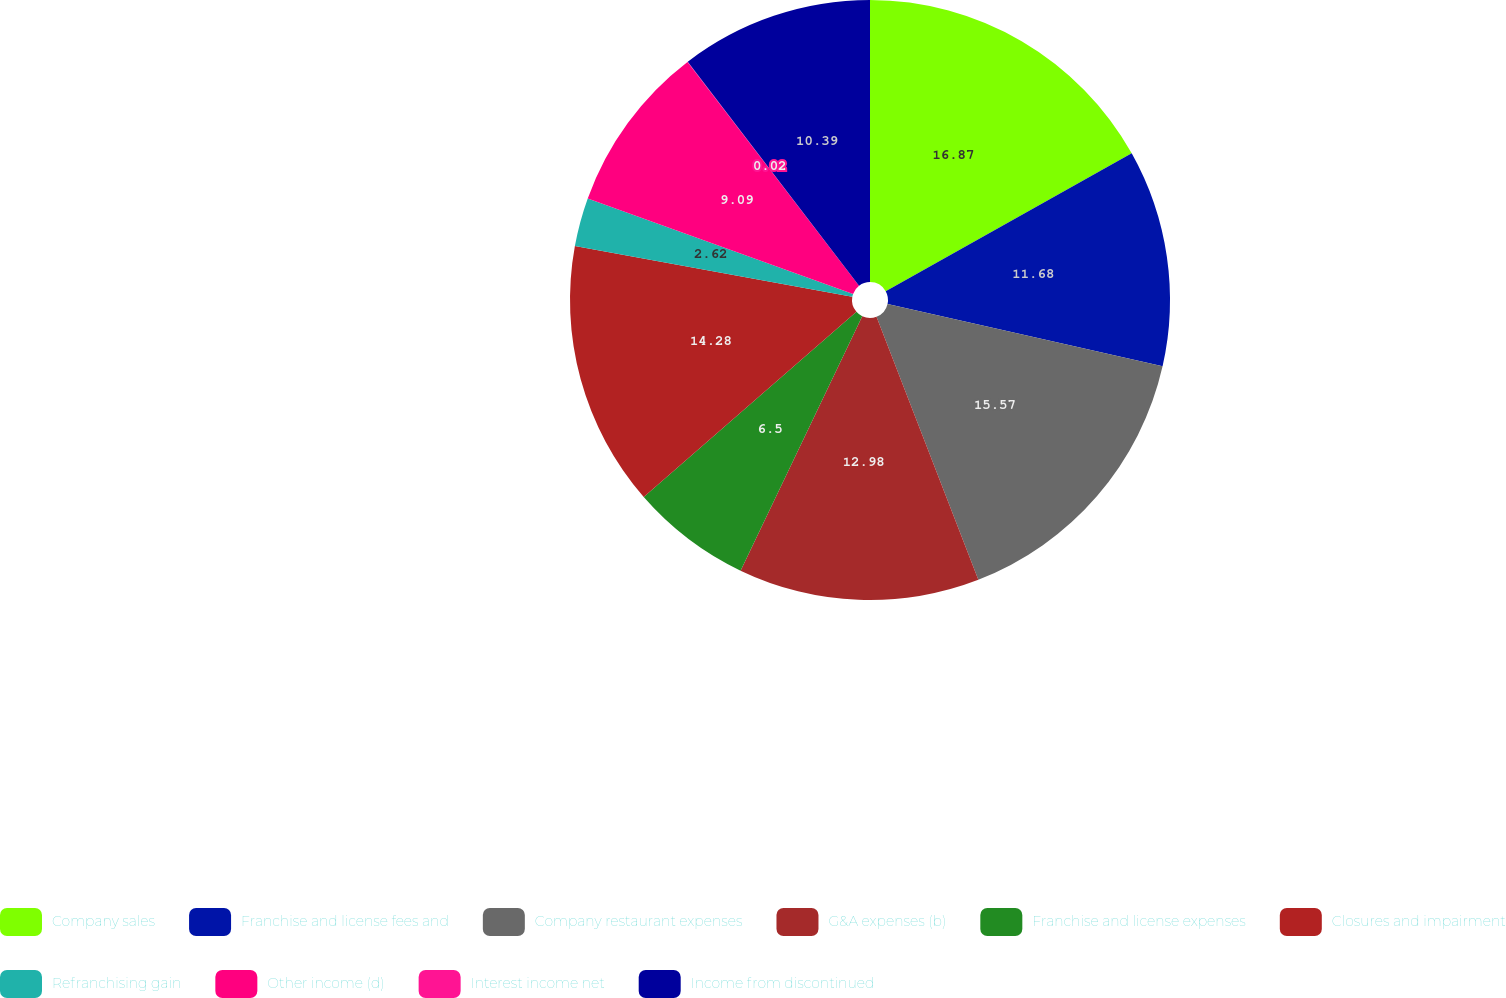Convert chart. <chart><loc_0><loc_0><loc_500><loc_500><pie_chart><fcel>Company sales<fcel>Franchise and license fees and<fcel>Company restaurant expenses<fcel>G&A expenses (b)<fcel>Franchise and license expenses<fcel>Closures and impairment<fcel>Refranchising gain<fcel>Other income (d)<fcel>Interest income net<fcel>Income from discontinued<nl><fcel>16.87%<fcel>11.68%<fcel>15.57%<fcel>12.98%<fcel>6.5%<fcel>14.28%<fcel>2.62%<fcel>9.09%<fcel>0.02%<fcel>10.39%<nl></chart> 